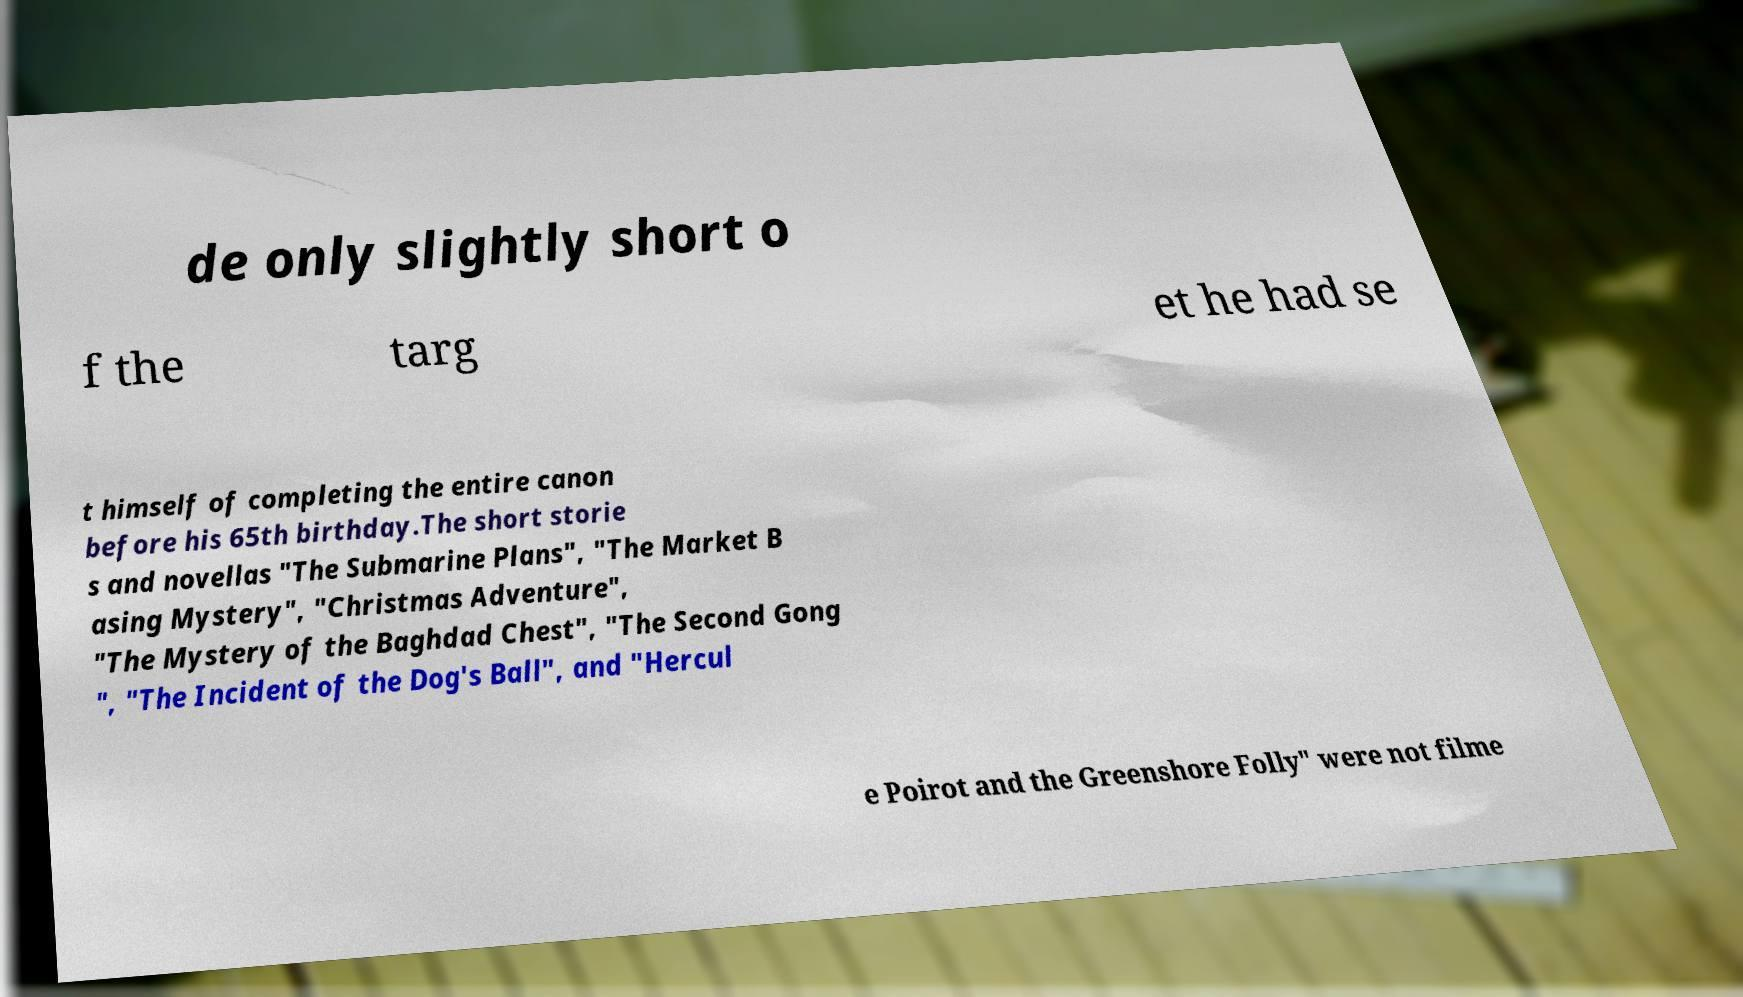There's text embedded in this image that I need extracted. Can you transcribe it verbatim? de only slightly short o f the targ et he had se t himself of completing the entire canon before his 65th birthday.The short storie s and novellas "The Submarine Plans", "The Market B asing Mystery", "Christmas Adventure", "The Mystery of the Baghdad Chest", "The Second Gong ", "The Incident of the Dog's Ball", and "Hercul e Poirot and the Greenshore Folly" were not filme 